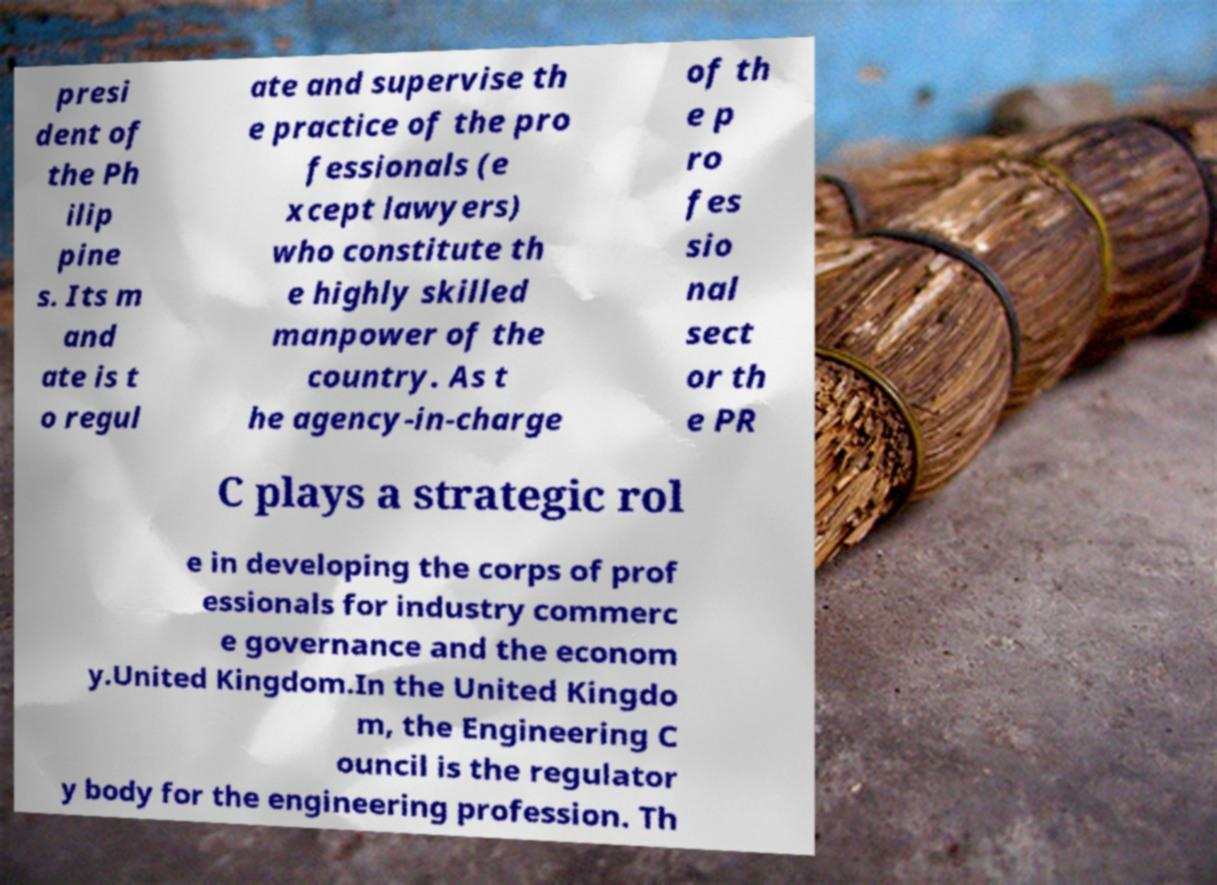There's text embedded in this image that I need extracted. Can you transcribe it verbatim? presi dent of the Ph ilip pine s. Its m and ate is t o regul ate and supervise th e practice of the pro fessionals (e xcept lawyers) who constitute th e highly skilled manpower of the country. As t he agency-in-charge of th e p ro fes sio nal sect or th e PR C plays a strategic rol e in developing the corps of prof essionals for industry commerc e governance and the econom y.United Kingdom.In the United Kingdo m, the Engineering C ouncil is the regulator y body for the engineering profession. Th 